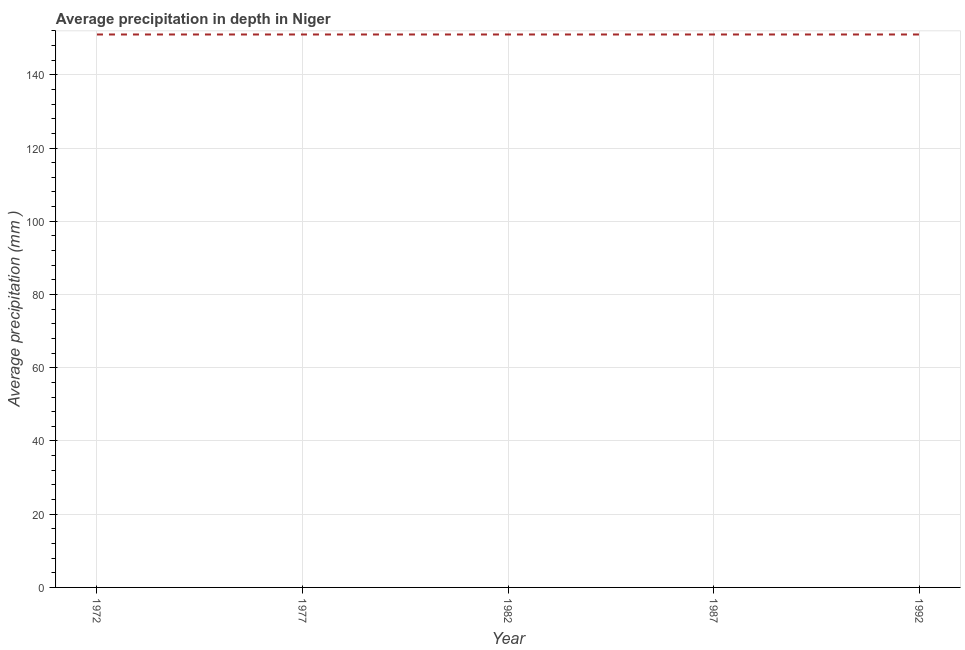What is the average precipitation in depth in 1992?
Your answer should be very brief. 151. Across all years, what is the maximum average precipitation in depth?
Keep it short and to the point. 151. Across all years, what is the minimum average precipitation in depth?
Give a very brief answer. 151. In which year was the average precipitation in depth maximum?
Make the answer very short. 1972. In which year was the average precipitation in depth minimum?
Keep it short and to the point. 1972. What is the sum of the average precipitation in depth?
Make the answer very short. 755. What is the average average precipitation in depth per year?
Your answer should be compact. 151. What is the median average precipitation in depth?
Keep it short and to the point. 151. What is the ratio of the average precipitation in depth in 1972 to that in 1987?
Your answer should be compact. 1. Is the sum of the average precipitation in depth in 1987 and 1992 greater than the maximum average precipitation in depth across all years?
Provide a succinct answer. Yes. In how many years, is the average precipitation in depth greater than the average average precipitation in depth taken over all years?
Make the answer very short. 0. Does the average precipitation in depth monotonically increase over the years?
Make the answer very short. No. How many lines are there?
Your response must be concise. 1. Does the graph contain any zero values?
Your answer should be compact. No. Does the graph contain grids?
Your response must be concise. Yes. What is the title of the graph?
Give a very brief answer. Average precipitation in depth in Niger. What is the label or title of the X-axis?
Your answer should be compact. Year. What is the label or title of the Y-axis?
Make the answer very short. Average precipitation (mm ). What is the Average precipitation (mm ) of 1972?
Give a very brief answer. 151. What is the Average precipitation (mm ) in 1977?
Provide a succinct answer. 151. What is the Average precipitation (mm ) in 1982?
Make the answer very short. 151. What is the Average precipitation (mm ) of 1987?
Keep it short and to the point. 151. What is the Average precipitation (mm ) in 1992?
Your response must be concise. 151. What is the difference between the Average precipitation (mm ) in 1972 and 1987?
Make the answer very short. 0. What is the difference between the Average precipitation (mm ) in 1977 and 1982?
Give a very brief answer. 0. What is the difference between the Average precipitation (mm ) in 1982 and 1992?
Provide a short and direct response. 0. What is the difference between the Average precipitation (mm ) in 1987 and 1992?
Offer a very short reply. 0. What is the ratio of the Average precipitation (mm ) in 1972 to that in 1977?
Make the answer very short. 1. What is the ratio of the Average precipitation (mm ) in 1972 to that in 1987?
Give a very brief answer. 1. What is the ratio of the Average precipitation (mm ) in 1977 to that in 1982?
Provide a succinct answer. 1. What is the ratio of the Average precipitation (mm ) in 1977 to that in 1987?
Your answer should be very brief. 1. 